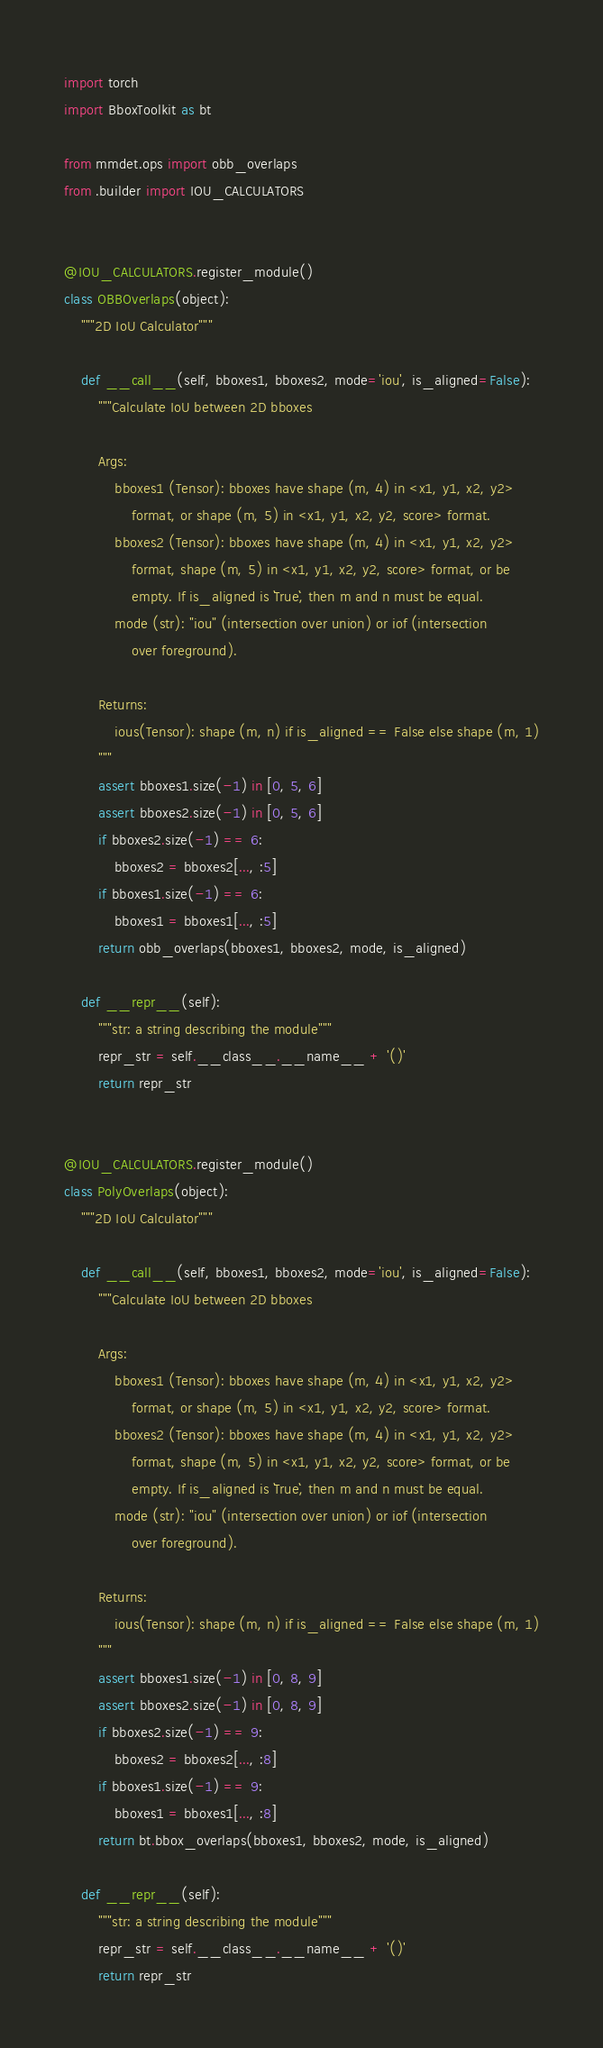Convert code to text. <code><loc_0><loc_0><loc_500><loc_500><_Python_>import torch
import BboxToolkit as bt

from mmdet.ops import obb_overlaps
from .builder import IOU_CALCULATORS


@IOU_CALCULATORS.register_module()
class OBBOverlaps(object):
    """2D IoU Calculator"""

    def __call__(self, bboxes1, bboxes2, mode='iou', is_aligned=False):
        """Calculate IoU between 2D bboxes

        Args:
            bboxes1 (Tensor): bboxes have shape (m, 4) in <x1, y1, x2, y2>
                format, or shape (m, 5) in <x1, y1, x2, y2, score> format.
            bboxes2 (Tensor): bboxes have shape (m, 4) in <x1, y1, x2, y2>
                format, shape (m, 5) in <x1, y1, x2, y2, score> format, or be
                empty. If is_aligned is ``True``, then m and n must be equal.
            mode (str): "iou" (intersection over union) or iof (intersection
                over foreground).

        Returns:
            ious(Tensor): shape (m, n) if is_aligned == False else shape (m, 1)
        """
        assert bboxes1.size(-1) in [0, 5, 6]
        assert bboxes2.size(-1) in [0, 5, 6]
        if bboxes2.size(-1) == 6:
            bboxes2 = bboxes2[..., :5]
        if bboxes1.size(-1) == 6:
            bboxes1 = bboxes1[..., :5]
        return obb_overlaps(bboxes1, bboxes2, mode, is_aligned)

    def __repr__(self):
        """str: a string describing the module"""
        repr_str = self.__class__.__name__ + '()'
        return repr_str


@IOU_CALCULATORS.register_module()
class PolyOverlaps(object):
    """2D IoU Calculator"""

    def __call__(self, bboxes1, bboxes2, mode='iou', is_aligned=False):
        """Calculate IoU between 2D bboxes

        Args:
            bboxes1 (Tensor): bboxes have shape (m, 4) in <x1, y1, x2, y2>
                format, or shape (m, 5) in <x1, y1, x2, y2, score> format.
            bboxes2 (Tensor): bboxes have shape (m, 4) in <x1, y1, x2, y2>
                format, shape (m, 5) in <x1, y1, x2, y2, score> format, or be
                empty. If is_aligned is ``True``, then m and n must be equal.
            mode (str): "iou" (intersection over union) or iof (intersection
                over foreground).

        Returns:
            ious(Tensor): shape (m, n) if is_aligned == False else shape (m, 1)
        """
        assert bboxes1.size(-1) in [0, 8, 9]
        assert bboxes2.size(-1) in [0, 8, 9]
        if bboxes2.size(-1) == 9:
            bboxes2 = bboxes2[..., :8]
        if bboxes1.size(-1) == 9:
            bboxes1 = bboxes1[..., :8]
        return bt.bbox_overlaps(bboxes1, bboxes2, mode, is_aligned)

    def __repr__(self):
        """str: a string describing the module"""
        repr_str = self.__class__.__name__ + '()'
        return repr_str
</code> 